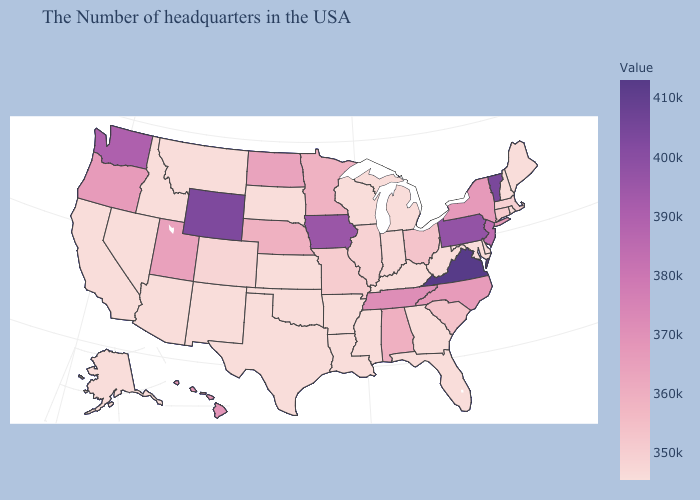Does Tennessee have the lowest value in the South?
Write a very short answer. No. Which states have the lowest value in the MidWest?
Answer briefly. Michigan, Wisconsin, Kansas, South Dakota. Which states have the highest value in the USA?
Be succinct. Virginia. Does Iowa have the highest value in the MidWest?
Keep it brief. Yes. Does the map have missing data?
Keep it brief. No. 